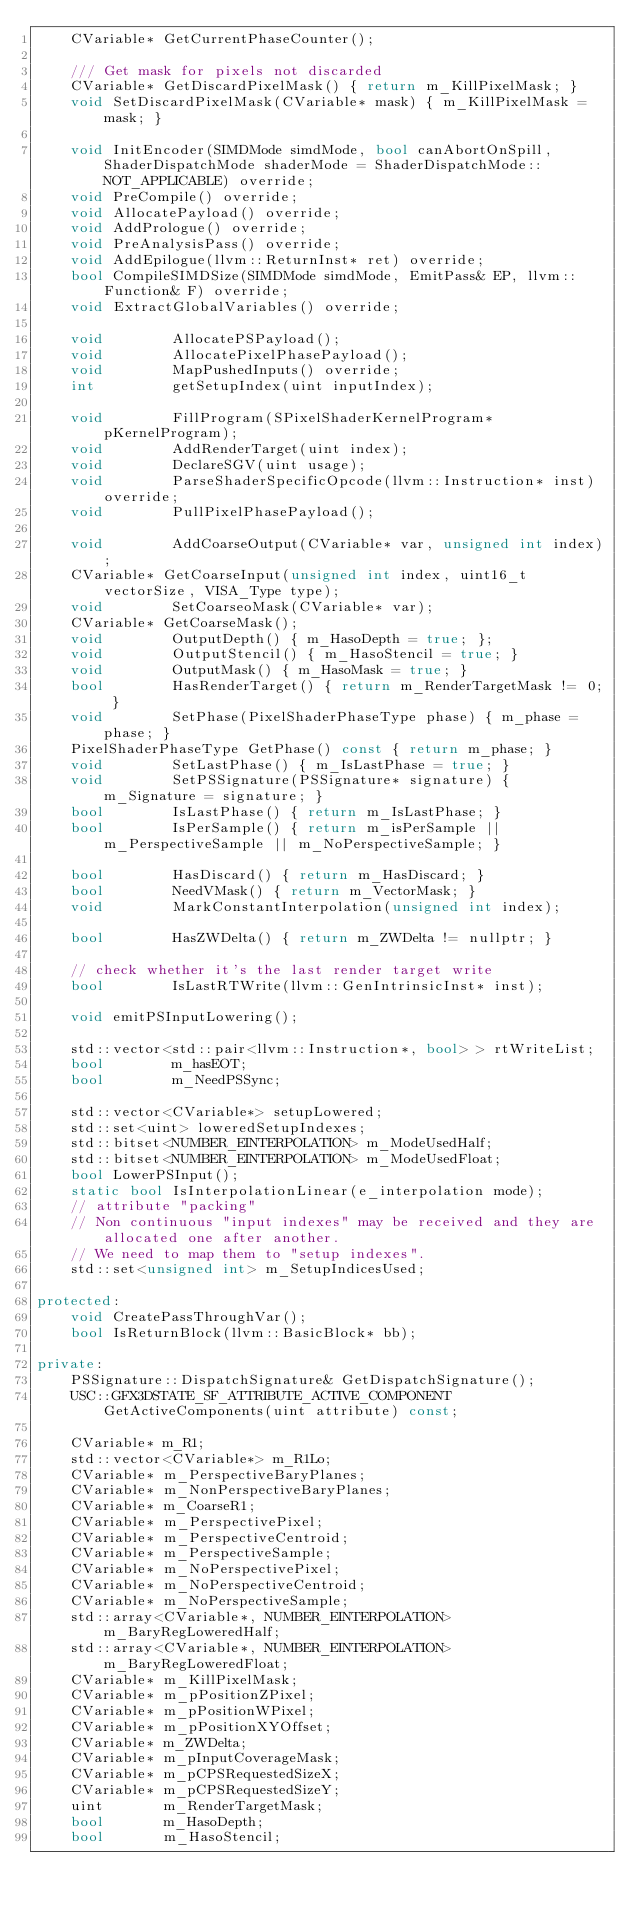<code> <loc_0><loc_0><loc_500><loc_500><_C++_>    CVariable* GetCurrentPhaseCounter();

    /// Get mask for pixels not discarded
    CVariable* GetDiscardPixelMask() { return m_KillPixelMask; }
    void SetDiscardPixelMask(CVariable* mask) { m_KillPixelMask = mask; }

    void InitEncoder(SIMDMode simdMode, bool canAbortOnSpill, ShaderDispatchMode shaderMode = ShaderDispatchMode::NOT_APPLICABLE) override;
    void PreCompile() override;
    void AllocatePayload() override;
    void AddPrologue() override;
    void PreAnalysisPass() override;
    void AddEpilogue(llvm::ReturnInst* ret) override;
    bool CompileSIMDSize(SIMDMode simdMode, EmitPass& EP, llvm::Function& F) override;
    void ExtractGlobalVariables() override;

    void        AllocatePSPayload();
    void        AllocatePixelPhasePayload();
    void        MapPushedInputs() override;
    int         getSetupIndex(uint inputIndex);

    void        FillProgram(SPixelShaderKernelProgram* pKernelProgram);
    void        AddRenderTarget(uint index);
    void        DeclareSGV(uint usage);
    void        ParseShaderSpecificOpcode(llvm::Instruction* inst) override;
    void        PullPixelPhasePayload();

    void        AddCoarseOutput(CVariable* var, unsigned int index);
    CVariable* GetCoarseInput(unsigned int index, uint16_t vectorSize, VISA_Type type);
    void        SetCoarseoMask(CVariable* var);
    CVariable* GetCoarseMask();
    void        OutputDepth() { m_HasoDepth = true; };
    void        OutputStencil() { m_HasoStencil = true; }
    void        OutputMask() { m_HasoMask = true; }
    bool        HasRenderTarget() { return m_RenderTargetMask != 0; }
    void        SetPhase(PixelShaderPhaseType phase) { m_phase = phase; }
    PixelShaderPhaseType GetPhase() const { return m_phase; }
    void        SetLastPhase() { m_IsLastPhase = true; }
    void        SetPSSignature(PSSignature* signature) { m_Signature = signature; }
    bool        IsLastPhase() { return m_IsLastPhase; }
    bool        IsPerSample() { return m_isPerSample || m_PerspectiveSample || m_NoPerspectiveSample; }

    bool        HasDiscard() { return m_HasDiscard; }
    bool        NeedVMask() { return m_VectorMask; }
    void        MarkConstantInterpolation(unsigned int index);

    bool        HasZWDelta() { return m_ZWDelta != nullptr; }

    // check whether it's the last render target write
    bool        IsLastRTWrite(llvm::GenIntrinsicInst* inst);

    void emitPSInputLowering();

    std::vector<std::pair<llvm::Instruction*, bool> > rtWriteList;
    bool        m_hasEOT;
    bool        m_NeedPSSync;

    std::vector<CVariable*> setupLowered;
    std::set<uint> loweredSetupIndexes;
    std::bitset<NUMBER_EINTERPOLATION> m_ModeUsedHalf;
    std::bitset<NUMBER_EINTERPOLATION> m_ModeUsedFloat;
    bool LowerPSInput();
    static bool IsInterpolationLinear(e_interpolation mode);
    // attribute "packing"
    // Non continuous "input indexes" may be received and they are allocated one after another.
    // We need to map them to "setup indexes".
    std::set<unsigned int> m_SetupIndicesUsed;

protected:
    void CreatePassThroughVar();
    bool IsReturnBlock(llvm::BasicBlock* bb);

private:
    PSSignature::DispatchSignature& GetDispatchSignature();
    USC::GFX3DSTATE_SF_ATTRIBUTE_ACTIVE_COMPONENT GetActiveComponents(uint attribute) const;

    CVariable* m_R1;
    std::vector<CVariable*> m_R1Lo;
    CVariable* m_PerspectiveBaryPlanes;
    CVariable* m_NonPerspectiveBaryPlanes;
    CVariable* m_CoarseR1;
    CVariable* m_PerspectivePixel;
    CVariable* m_PerspectiveCentroid;
    CVariable* m_PerspectiveSample;
    CVariable* m_NoPerspectivePixel;
    CVariable* m_NoPerspectiveCentroid;
    CVariable* m_NoPerspectiveSample;
    std::array<CVariable*, NUMBER_EINTERPOLATION> m_BaryRegLoweredHalf;
    std::array<CVariable*, NUMBER_EINTERPOLATION> m_BaryRegLoweredFloat;
    CVariable* m_KillPixelMask;
    CVariable* m_pPositionZPixel;
    CVariable* m_pPositionWPixel;
    CVariable* m_pPositionXYOffset;
    CVariable* m_ZWDelta;
    CVariable* m_pInputCoverageMask;
    CVariable* m_pCPSRequestedSizeX;
    CVariable* m_pCPSRequestedSizeY;
    uint       m_RenderTargetMask;
    bool       m_HasoDepth;
    bool       m_HasoStencil;</code> 